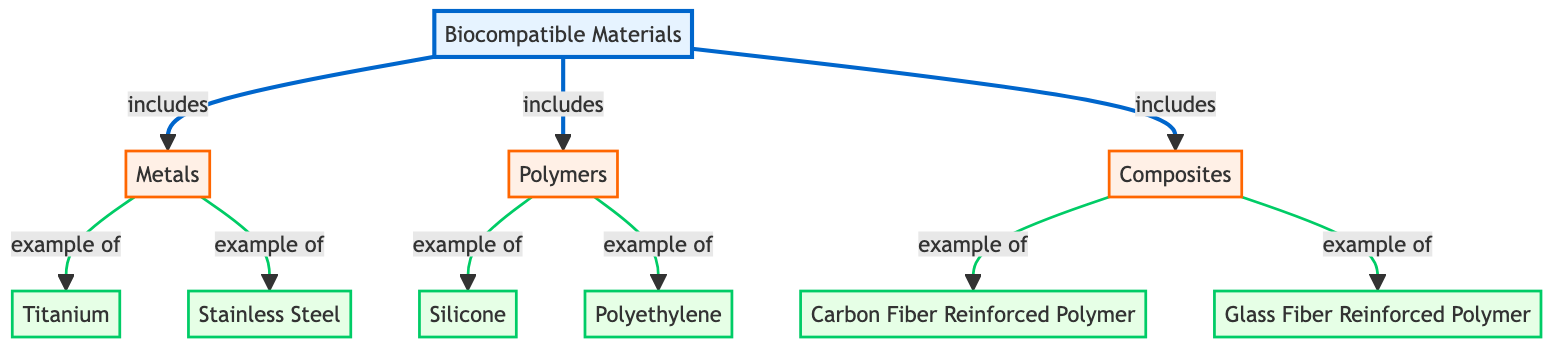What are the three main categories of biocompatible materials? The diagram directly lists three categories under "Biocompatible Materials," which are "Metals," "Polymers," and "Composites."
Answer: Metals, Polymers, Composites How many example materials are listed under the "Metals" category? The diagram shows two examples branching from the "Metals" category: "Titanium" and "Stainless Steel." This indicates a total of two examples.
Answer: 2 Which type of material includes "Silicone" as an example? "Silicone" is listed as an example under the "Polymers" category in the diagram. Following the linkages, it is clear that "Silicone" belongs to "Polymers."
Answer: Polymers What examples are provided under the "Composites" category? The diagram presents two examples under the "Composites" category: "Carbon Fiber Reinforced Polymer" and "Glass Fiber Reinforced Polymer." Thus, both names constitute the examples of composites.
Answer: Carbon Fiber Reinforced Polymer, Glass Fiber Reinforced Polymer What is the direct relationship between "Titanium" and "Metals"? The diagram indicates that "Titanium" is an example of the category "Metals," as shown by the arrow leading from "Metals" to "Titanium." This directional link clarifies the relationship.
Answer: example of How many total examples are there among all categories combined? By counting the examples under each category ("2 under Metals," "2 under Polymers," and "2 under Composites"), we summarize the total as 2 + 2 + 2, which totals to 6 examples overall in the diagram.
Answer: 6 Which category does "Polyethylene" belong to? "Polyethylene" is identified as an example under "Polymers" in the diagram. The direct link connects it clearly to the "Polymers" category.
Answer: Polymers What color indicates the "main" category as per the diagram's styling? The "main" category is styled with a fill color indicated in the diagram code as light blue: "#e6f3ff." This is established through the class definition for the "main" category.
Answer: light blue Which example material is shown first under "Composites"? The first example listed under the "Composites" category in the diagram is "Carbon Fiber Reinforced Polymer" as per its sequence in the connections.
Answer: Carbon Fiber Reinforced Polymer 